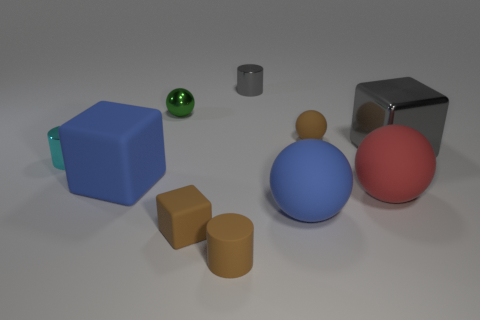Subtract all cyan cylinders. How many cylinders are left? 2 Subtract all matte balls. How many balls are left? 1 Subtract all cylinders. How many objects are left? 7 Subtract all brown blocks. How many yellow balls are left? 0 Subtract all tiny cyan cylinders. Subtract all blue spheres. How many objects are left? 8 Add 4 large cubes. How many large cubes are left? 6 Add 5 small purple matte cylinders. How many small purple matte cylinders exist? 5 Subtract 0 cyan spheres. How many objects are left? 10 Subtract 1 cylinders. How many cylinders are left? 2 Subtract all red cylinders. Subtract all red spheres. How many cylinders are left? 3 